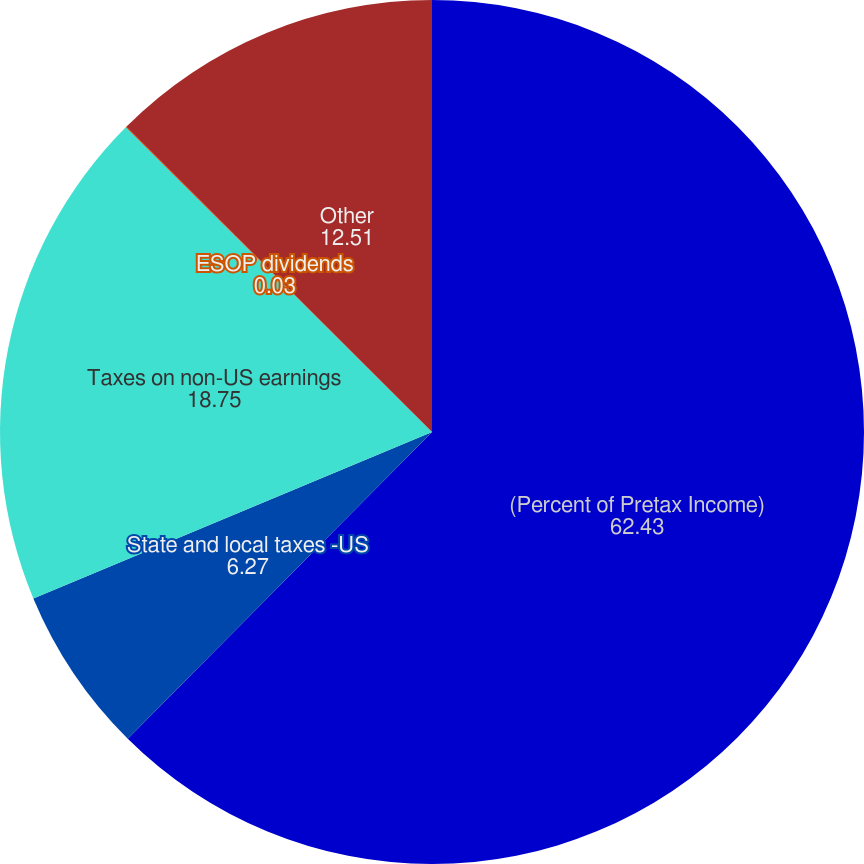<chart> <loc_0><loc_0><loc_500><loc_500><pie_chart><fcel>(Percent of Pretax Income)<fcel>State and local taxes -US<fcel>Taxes on non-US earnings<fcel>ESOP dividends<fcel>Other<nl><fcel>62.43%<fcel>6.27%<fcel>18.75%<fcel>0.03%<fcel>12.51%<nl></chart> 